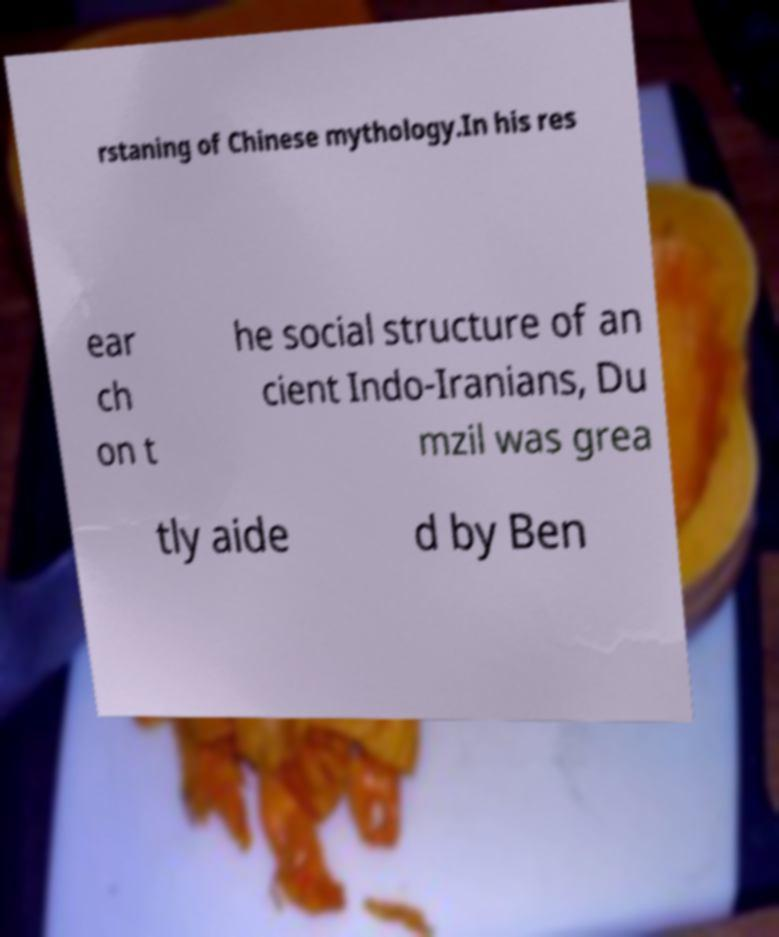There's text embedded in this image that I need extracted. Can you transcribe it verbatim? rstaning of Chinese mythology.In his res ear ch on t he social structure of an cient Indo-Iranians, Du mzil was grea tly aide d by Ben 